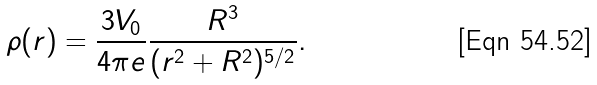Convert formula to latex. <formula><loc_0><loc_0><loc_500><loc_500>\rho ( r ) = \frac { 3 V _ { 0 } } { 4 \pi e } \frac { R ^ { 3 } } { ( r ^ { 2 } + R ^ { 2 } ) ^ { 5 / 2 } } .</formula> 